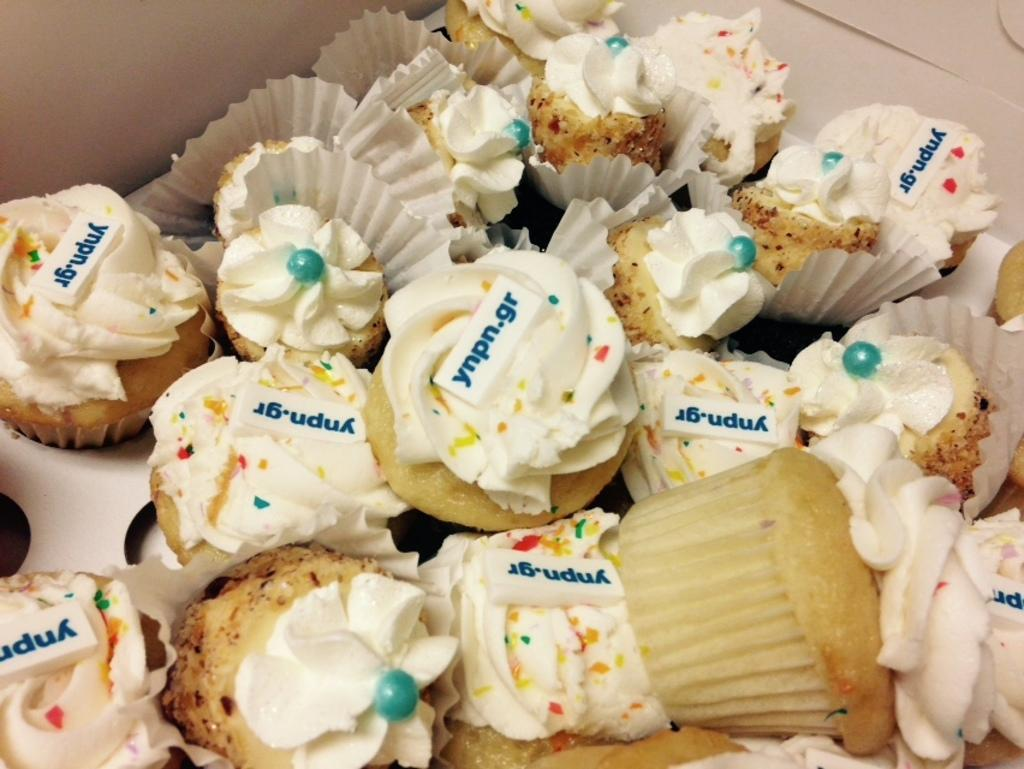What type of food is visible in the image? There are cupcakes in the image. How are the cupcakes contained or organized? The cupcakes are in a box. What is written or printed on the cupcakes? There is text on the cupcakes. What can be seen in the background of the image? There is a wall visible towards the top of the image. What type of substance is being taught in the image? There is no indication of any teaching or substance being taught in the image; it primarily features cupcakes in a box. 